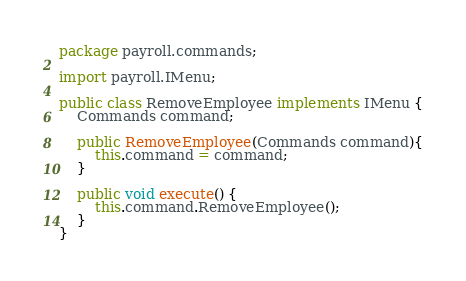<code> <loc_0><loc_0><loc_500><loc_500><_Java_>package payroll.commands;

import payroll.IMenu;

public class RemoveEmployee implements IMenu {
    Commands command;

    public RemoveEmployee(Commands command){
        this.command = command;
    }

    public void execute() {
        this.command.RemoveEmployee();
    }
}</code> 